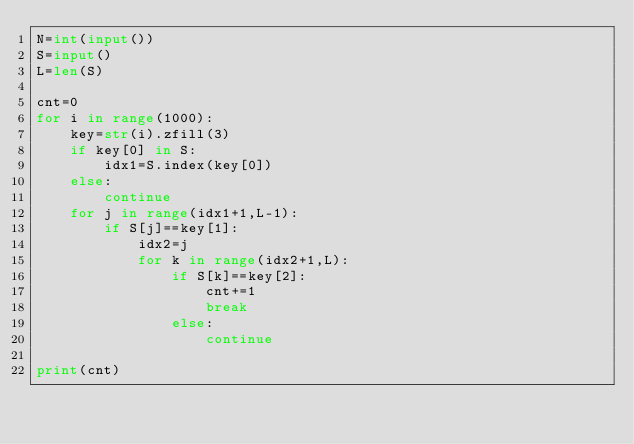Convert code to text. <code><loc_0><loc_0><loc_500><loc_500><_Python_>N=int(input())
S=input()
L=len(S)

cnt=0
for i in range(1000):
    key=str(i).zfill(3)
    if key[0] in S:
        idx1=S.index(key[0])
    else:
        continue
    for j in range(idx1+1,L-1):
        if S[j]==key[1]:
            idx2=j
            for k in range(idx2+1,L):
                if S[k]==key[2]:
                    cnt+=1
                    break
                else:
                    continue

print(cnt)
</code> 